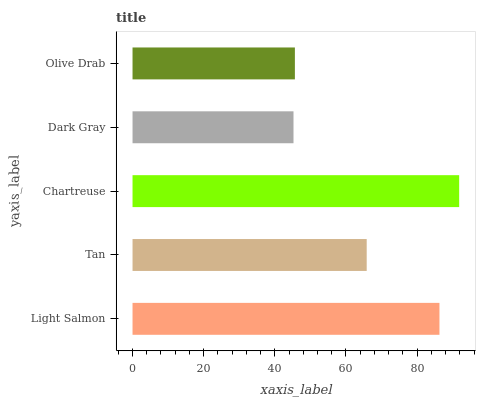Is Dark Gray the minimum?
Answer yes or no. Yes. Is Chartreuse the maximum?
Answer yes or no. Yes. Is Tan the minimum?
Answer yes or no. No. Is Tan the maximum?
Answer yes or no. No. Is Light Salmon greater than Tan?
Answer yes or no. Yes. Is Tan less than Light Salmon?
Answer yes or no. Yes. Is Tan greater than Light Salmon?
Answer yes or no. No. Is Light Salmon less than Tan?
Answer yes or no. No. Is Tan the high median?
Answer yes or no. Yes. Is Tan the low median?
Answer yes or no. Yes. Is Olive Drab the high median?
Answer yes or no. No. Is Dark Gray the low median?
Answer yes or no. No. 